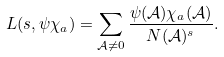<formula> <loc_0><loc_0><loc_500><loc_500>L ( s , \psi \chi _ { a } ) = \sum _ { \mathcal { A } \neq 0 } \frac { \psi ( \mathcal { A } ) \chi _ { a } ( \mathcal { A } ) } { N ( \mathcal { A } ) ^ { s } } .</formula> 